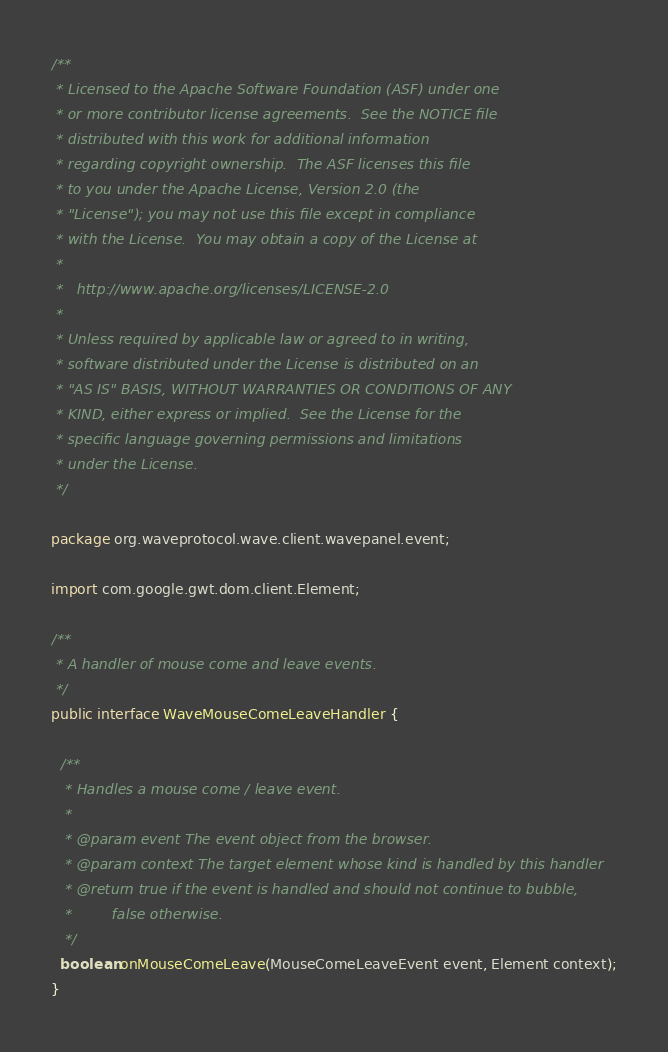Convert code to text. <code><loc_0><loc_0><loc_500><loc_500><_Java_>/**
 * Licensed to the Apache Software Foundation (ASF) under one
 * or more contributor license agreements.  See the NOTICE file
 * distributed with this work for additional information
 * regarding copyright ownership.  The ASF licenses this file
 * to you under the Apache License, Version 2.0 (the
 * "License"); you may not use this file except in compliance
 * with the License.  You may obtain a copy of the License at
 *
 *   http://www.apache.org/licenses/LICENSE-2.0
 *
 * Unless required by applicable law or agreed to in writing,
 * software distributed under the License is distributed on an
 * "AS IS" BASIS, WITHOUT WARRANTIES OR CONDITIONS OF ANY
 * KIND, either express or implied.  See the License for the
 * specific language governing permissions and limitations
 * under the License.
 */

package org.waveprotocol.wave.client.wavepanel.event;

import com.google.gwt.dom.client.Element;

/**
 * A handler of mouse come and leave events.
 */
public interface WaveMouseComeLeaveHandler {
  
  /**
   * Handles a mouse come / leave event.
   *
   * @param event The event object from the browser.
   * @param context The target element whose kind is handled by this handler
   * @return true if the event is handled and should not continue to bubble,
   *         false otherwise.
   */  
  boolean onMouseComeLeave(MouseComeLeaveEvent event, Element context);
}</code> 